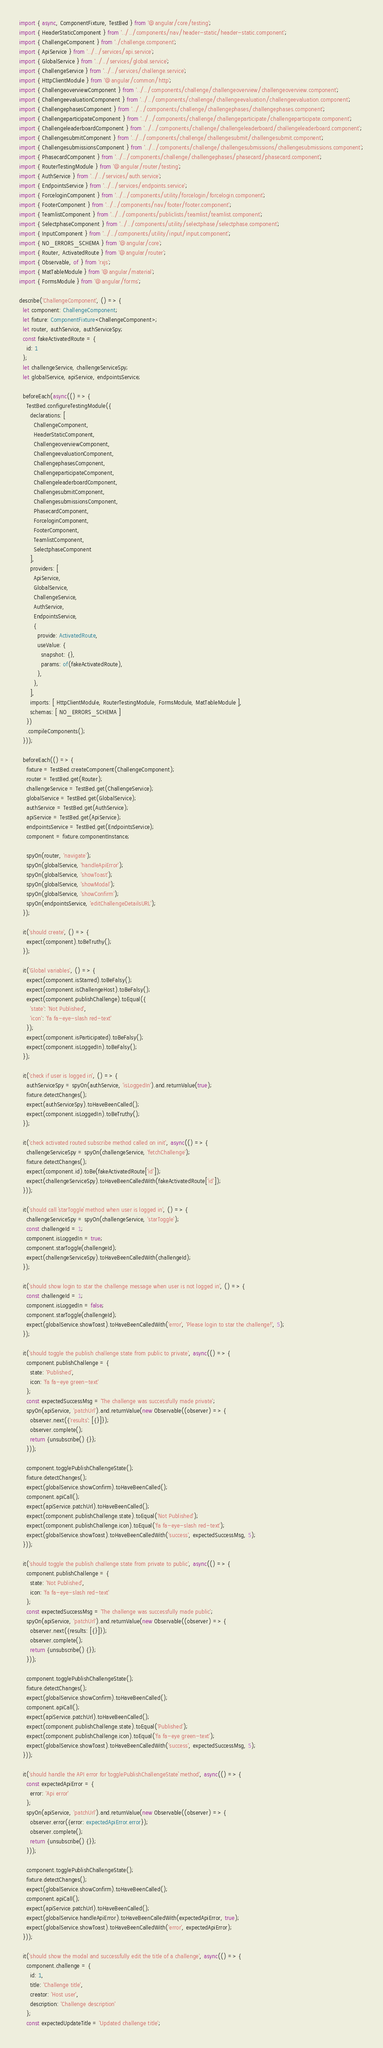<code> <loc_0><loc_0><loc_500><loc_500><_TypeScript_>import { async, ComponentFixture, TestBed } from '@angular/core/testing';
import { HeaderStaticComponent } from '../../components/nav/header-static/header-static.component';
import { ChallengeComponent } from './challenge.component';
import { ApiService } from '../../services/api.service';
import { GlobalService } from '../../services/global.service';
import { ChallengeService } from '../../services/challenge.service';
import { HttpClientModule } from '@angular/common/http';
import { ChallengeoverviewComponent } from '../../components/challenge/challengeoverview/challengeoverview.component';
import { ChallengeevaluationComponent } from '../../components/challenge/challengeevaluation/challengeevaluation.component';
import { ChallengephasesComponent } from '../../components/challenge/challengephases/challengephases.component';
import { ChallengeparticipateComponent } from '../../components/challenge/challengeparticipate/challengeparticipate.component';
import { ChallengeleaderboardComponent } from '../../components/challenge/challengeleaderboard/challengeleaderboard.component';
import { ChallengesubmitComponent } from '../../components/challenge/challengesubmit/challengesubmit.component';
import { ChallengesubmissionsComponent } from '../../components/challenge/challengesubmissions/challengesubmissions.component';
import { PhasecardComponent } from '../../components/challenge/challengephases/phasecard/phasecard.component';
import { RouterTestingModule } from '@angular/router/testing';
import { AuthService } from '../../services/auth.service';
import { EndpointsService } from '../../services/endpoints.service';
import { ForceloginComponent } from '../../components/utility/forcelogin/forcelogin.component';
import { FooterComponent } from '../../components/nav/footer/footer.component';
import { TeamlistComponent } from '../../components/publiclists/teamlist/teamlist.component';
import { SelectphaseComponent } from '../../components/utility/selectphase/selectphase.component';
import { InputComponent } from '../../components/utility/input/input.component';
import { NO_ERRORS_SCHEMA } from '@angular/core';
import { Router, ActivatedRoute } from '@angular/router';
import { Observable, of } from 'rxjs';
import { MatTableModule } from '@angular/material';
import { FormsModule } from '@angular/forms';

describe('ChallengeComponent', () => {
  let component: ChallengeComponent;
  let fixture: ComponentFixture<ChallengeComponent>;
  let router, authService, authServiceSpy;
  const fakeActivatedRoute = {
    id: 1
  };
  let challengeService, challengeServiceSpy;
  let globalService, apiService, endpointsService;

  beforeEach(async(() => {
    TestBed.configureTestingModule({
      declarations: [
        ChallengeComponent,
        HeaderStaticComponent,
        ChallengeoverviewComponent,
        ChallengeevaluationComponent,
        ChallengephasesComponent,
        ChallengeparticipateComponent,
        ChallengeleaderboardComponent,
        ChallengesubmitComponent,
        ChallengesubmissionsComponent,
        PhasecardComponent,
        ForceloginComponent,
        FooterComponent,
        TeamlistComponent,
        SelectphaseComponent
      ],
      providers: [
        ApiService,
        GlobalService,
        ChallengeService,
        AuthService,
        EndpointsService,
        {
          provide: ActivatedRoute,
          useValue: {
            snapshot: {},
            params: of(fakeActivatedRoute),
          },
        },
      ],
      imports: [ HttpClientModule, RouterTestingModule, FormsModule, MatTableModule ],
      schemas: [ NO_ERRORS_SCHEMA ]
    })
    .compileComponents();
  }));

  beforeEach(() => {
    fixture = TestBed.createComponent(ChallengeComponent);
    router = TestBed.get(Router);
    challengeService = TestBed.get(ChallengeService);
    globalService = TestBed.get(GlobalService);
    authService = TestBed.get(AuthService);
    apiService = TestBed.get(ApiService);
    endpointsService = TestBed.get(EndpointsService);
    component = fixture.componentInstance;

    spyOn(router, 'navigate');
    spyOn(globalService, 'handleApiError');
    spyOn(globalService, 'showToast');
    spyOn(globalService, 'showModal');
    spyOn(globalService, 'showConfirm');
    spyOn(endpointsService, 'editChallengeDetailsURL');
  });

  it('should create', () => {
    expect(component).toBeTruthy();
  });

  it('Global variables', () => {
    expect(component.isStarred).toBeFalsy();
    expect(component.isChallengeHost).toBeFalsy();
    expect(component.publishChallenge).toEqual({
      'state': 'Not Published',
      'icon': 'fa fa-eye-slash red-text'
    });
    expect(component.isParticipated).toBeFalsy();
    expect(component.isLoggedIn).toBeFalsy();
  });

  it('check if user is logged in', () => {
    authServiceSpy = spyOn(authService, 'isLoggedIn').and.returnValue(true);
    fixture.detectChanges();
    expect(authServiceSpy).toHaveBeenCalled();
    expect(component.isLoggedIn).toBeTruthy();
  });

  it('check activated routed subscribe method called on init', async(() => {
    challengeServiceSpy = spyOn(challengeService, 'fetchChallenge');
    fixture.detectChanges();
    expect(component.id).toBe(fakeActivatedRoute['id']);
    expect(challengeServiceSpy).toHaveBeenCalledWith(fakeActivatedRoute['id']);
  }));

  it('should call `starToggle` method when user is logged in', () => {
    challengeServiceSpy = spyOn(challengeService, 'starToggle');
    const challengeId = 1;
    component.isLoggedIn = true;
    component.starToggle(challengeId);
    expect(challengeServiceSpy).toHaveBeenCalledWith(challengeId);
  });

  it('should show login to star the challenge message when user is not logged in', () => {
    const challengeId = 1;
    component.isLoggedIn = false;
    component.starToggle(challengeId);
    expect(globalService.showToast).toHaveBeenCalledWith('error', 'Please login to star the challenge!', 5);
  });

  it('should toggle the publish challenge state from public to private', async(() => {
    component.publishChallenge = {
      state: 'Published',
      icon: 'fa fa-eye green-text'
    };
    const expectedSuccessMsg = 'The challenge was successfully made private';
    spyOn(apiService, 'patchUrl').and.returnValue(new Observable((observer) => {
      observer.next({'results': [{}]});
      observer.complete();
      return {unsubscribe() {}};
    }));

    component.togglePublishChallengeState();
    fixture.detectChanges();
    expect(globalService.showConfirm).toHaveBeenCalled();
    component.apiCall();
    expect(apiService.patchUrl).toHaveBeenCalled();
    expect(component.publishChallenge.state).toEqual('Not Published');
    expect(component.publishChallenge.icon).toEqual('fa fa-eye-slash red-text');
    expect(globalService.showToast).toHaveBeenCalledWith('success', expectedSuccessMsg, 5);
  }));

  it('should toggle the publish challenge state from private to public', async(() => {
    component.publishChallenge = {
      state: 'Not Published',
      icon: 'fa fa-eye-slash red-text'
    };
    const expectedSuccessMsg = 'The challenge was successfully made public';
    spyOn(apiService, 'patchUrl').and.returnValue(new Observable((observer) => {
      observer.next({results: [{}]});
      observer.complete();
      return {unsubscribe() {}};
    }));

    component.togglePublishChallengeState();
    fixture.detectChanges();
    expect(globalService.showConfirm).toHaveBeenCalled();
    component.apiCall();
    expect(apiService.patchUrl).toHaveBeenCalled();
    expect(component.publishChallenge.state).toEqual('Published');
    expect(component.publishChallenge.icon).toEqual('fa fa-eye green-text');
    expect(globalService.showToast).toHaveBeenCalledWith('success', expectedSuccessMsg, 5);
  }));

  it('should handle the API error for `togglePublishChallengeState` method', async(() => {
    const expectedApiError = {
      error: 'Api error'
    };
    spyOn(apiService, 'patchUrl').and.returnValue(new Observable((observer) => {
      observer.error({error: expectedApiError.error});
      observer.complete();
      return {unsubscribe() {}};
    }));

    component.togglePublishChallengeState();
    fixture.detectChanges();
    expect(globalService.showConfirm).toHaveBeenCalled();
    component.apiCall();
    expect(apiService.patchUrl).toHaveBeenCalled();
    expect(globalService.handleApiError).toHaveBeenCalledWith(expectedApiError, true);
    expect(globalService.showToast).toHaveBeenCalledWith('error', expectedApiError);
  }));

  it('should show the modal and successfully edit the title of a challenge', async(() => {
    component.challenge = {
      id: 1,
      title: 'Challenge title',
      creator: 'Host user',
      description: 'Challenge description'
    };
    const expectedUpdateTitle = 'Updated challenge title';</code> 